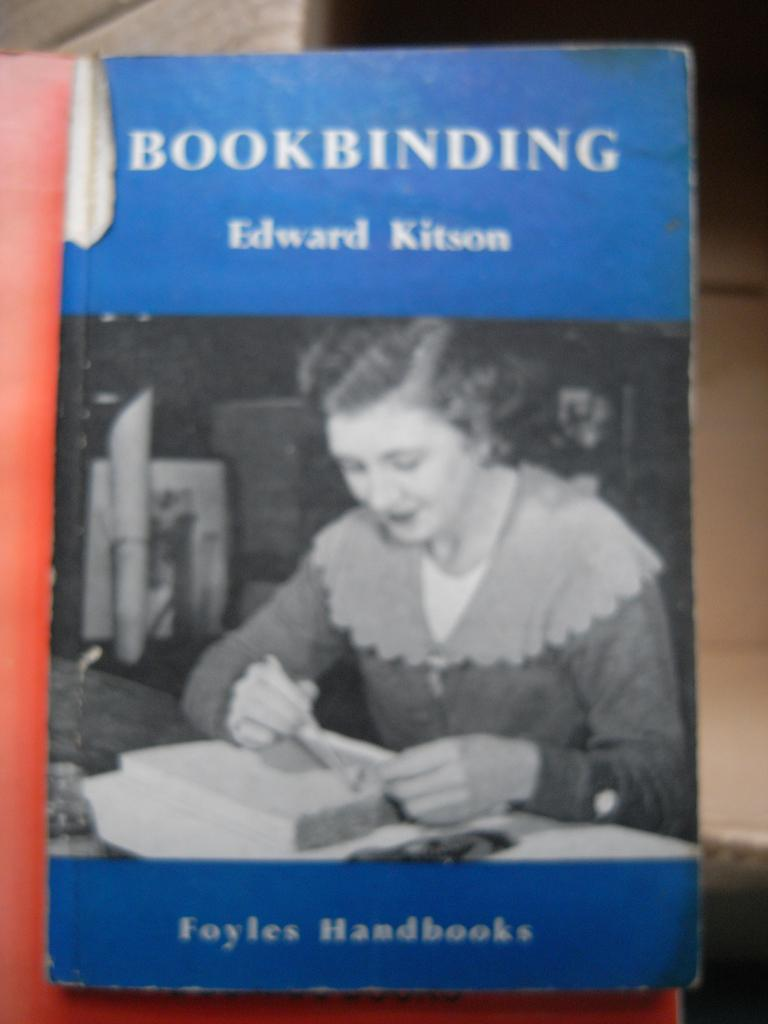Provide a one-sentence caption for the provided image. A book about book binding by Edward Kitson. 